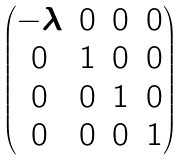Convert formula to latex. <formula><loc_0><loc_0><loc_500><loc_500>\begin{pmatrix} - \lambda & 0 & 0 & 0 \\ 0 & 1 & 0 & 0 \\ 0 & 0 & 1 & 0 \\ 0 & 0 & 0 & 1 \end{pmatrix}</formula> 